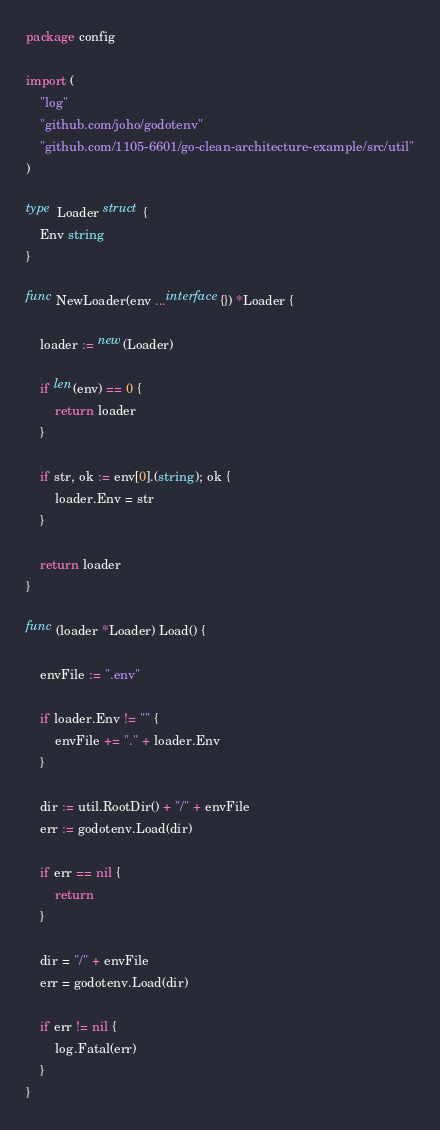Convert code to text. <code><loc_0><loc_0><loc_500><loc_500><_Go_>package config

import (
	"log"
	"github.com/joho/godotenv"
	"github.com/1105-6601/go-clean-architecture-example/src/util"
)

type Loader struct {
	Env string
}

func NewLoader(env ...interface{}) *Loader {

	loader := new(Loader)

	if len(env) == 0 {
		return loader
	}

	if str, ok := env[0].(string); ok {
		loader.Env = str
	}

	return loader
}

func (loader *Loader) Load() {

	envFile := ".env"

	if loader.Env != "" {
		envFile += "." + loader.Env
	}

	dir := util.RootDir() + "/" + envFile
	err := godotenv.Load(dir)

	if err == nil {
		return
	}

	dir = "/" + envFile
	err = godotenv.Load(dir)

	if err != nil {
		log.Fatal(err)
	}
}
</code> 